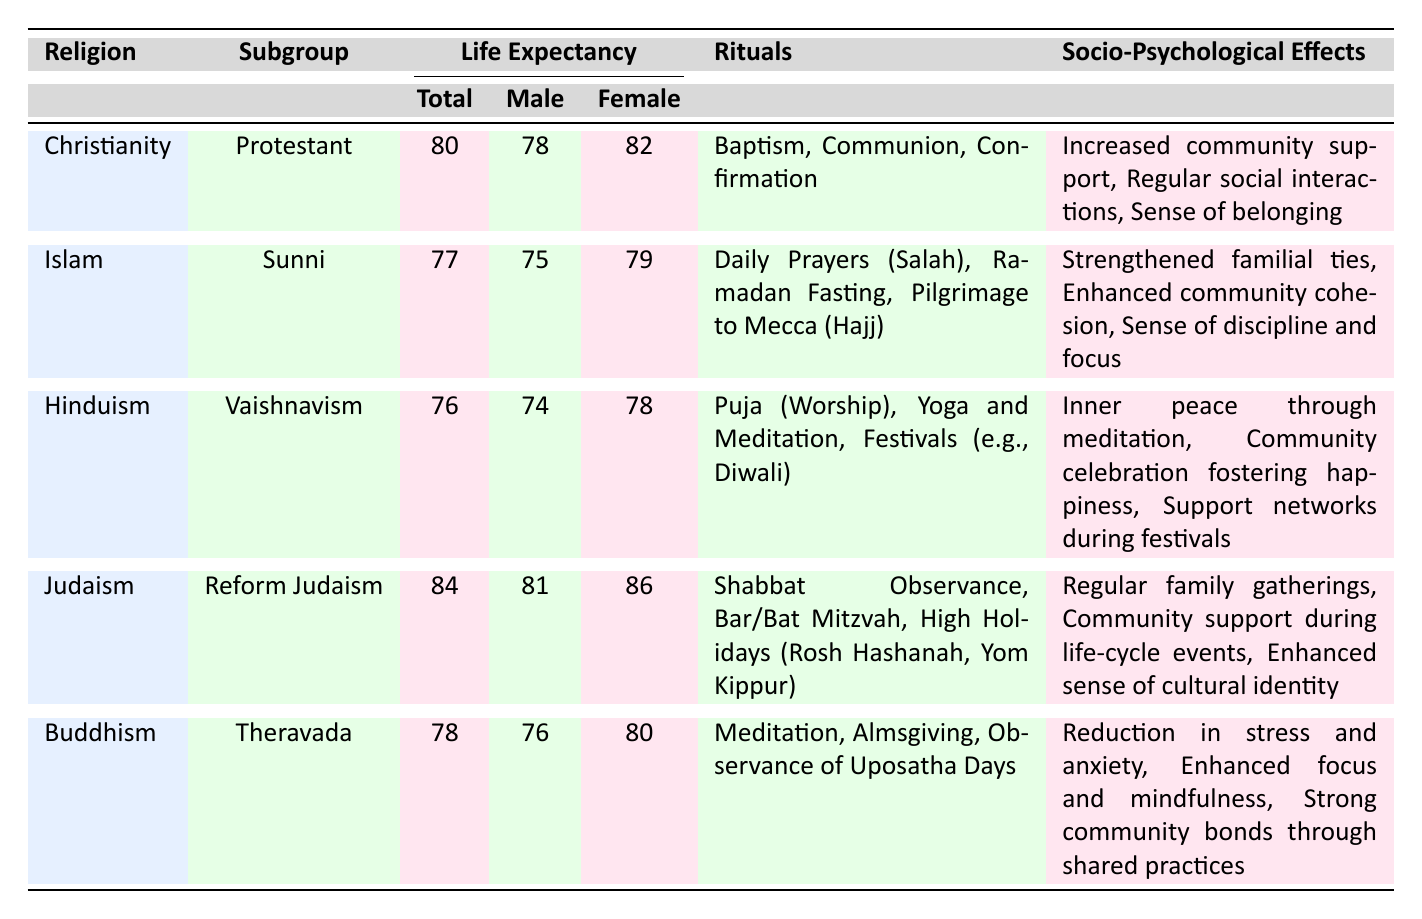What is the life expectancy for females in Reform Judaism? The table lists the life expectancy for females under the "Judaism" row, which is 86.
Answer: 86 Which religion has the highest overall life expectancy? By comparing the total life expectancy values of all religions in the table, Judaism has the highest at 84, while the others are lower.
Answer: Judaism What is the difference in life expectancy between male and female in Sunni Islam? The life expectancy for males is 75, and for females, it is 79. The difference is 79 - 75 = 4 years.
Answer: 4 Do Buddhism rituals include meditation? Looking at the "Rituals" section for Buddhism, "Meditation" is listed as one of the rituals.
Answer: Yes What is the average life expectancy for all listed religions? The total life expectancies are 80 (Christianity) + 77 (Islam) + 76 (Hinduism) + 84 (Judaism) + 78 (Buddhism) = 395. There are 5 religions, so the average is 395/5 = 79.
Answer: 79 Which religious community has the most rituals listed, and how many are there? Observing the "Rituals" section, Reform Judaism has 3 rituals listed, while the others also have 3, ensuring they are equally distributed with no community standing out in this aspect.
Answer: All have 3 rituals How do the socio-psychological effects of Hinduism and Judaism compare? Looking at the sections for socio-psychological effects, Hinduism lists "Inner peace through meditation," "Community celebration fostering happiness," and "Support networks during festivals," whereas Judaism lists "Regular family gatherings," "Community support during life-cycle events," and "Enhanced sense of cultural identity." This indicates both have strong social support aspects, but the emphasis is different: Hinduism focuses on personal and communal happiness, while Judaism emphasizes identity and family.
Answer: They are different in focus but equally strong What is the lowest life expectancy among the presented religions? The lowest total life expectancy can be identified by comparing all religion's total life expectancies, which shows that Hinduism has the lowest at 76.
Answer: 76 